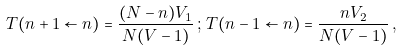<formula> <loc_0><loc_0><loc_500><loc_500>T ( n + 1 \leftarrow n ) = \frac { ( N - n ) V _ { 1 } } { N ( V - 1 ) } \, ; \, T ( n - 1 \leftarrow n ) = \frac { n V _ { 2 } } { N ( V - 1 ) } \, ,</formula> 